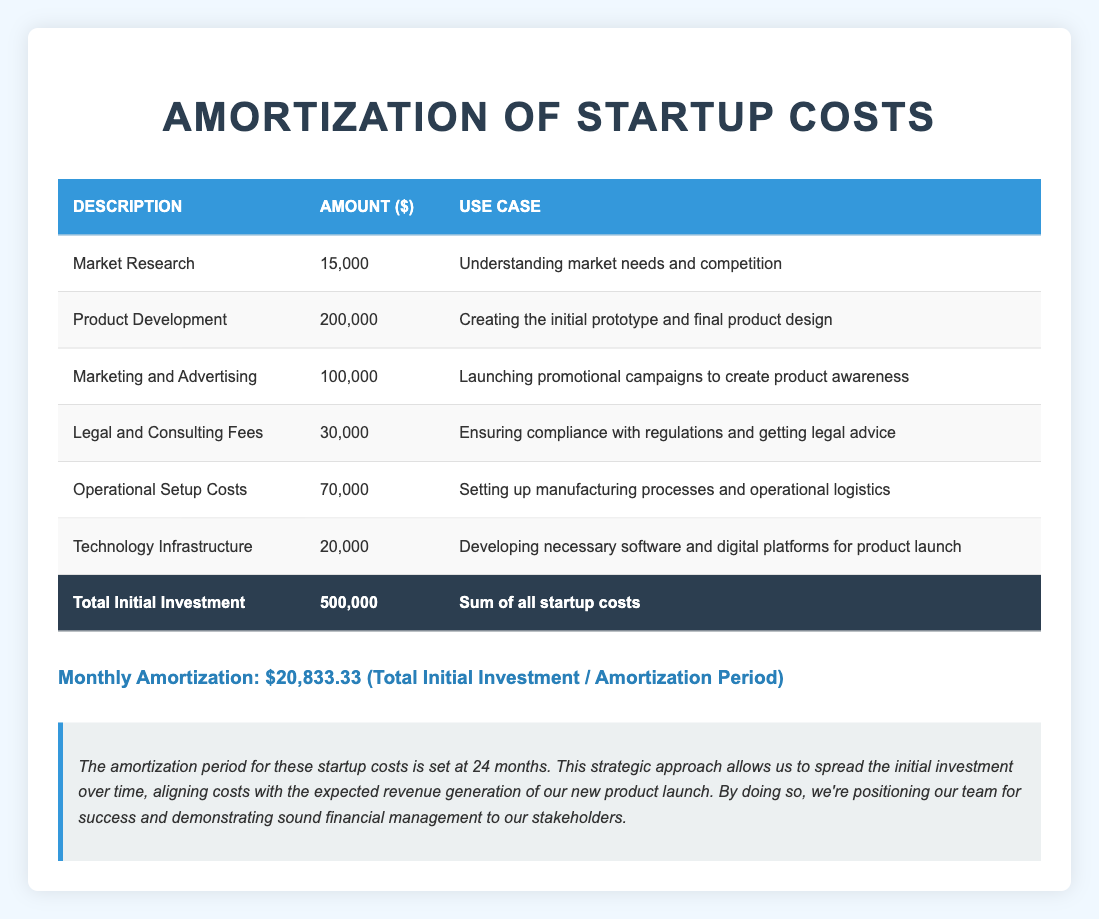What is the total amount allocated for product development? The total amount allocated for product development can be directly found in the table. It states "Product Development" and shows the amount of 200,000.
Answer: 200,000 What is the total initial investment for the startup costs? The total initial investment is listed at the bottom of the table as "Total Initial Investment" which shows 500,000.
Answer: 500,000 How much is allocated for marketing and advertising? The table indicates that the allocated amount for "Marketing and Advertising" is 100,000.
Answer: 100,000 Is the amount spent on legal and consulting fees more than the amount spent on technology infrastructure? By comparing the values in the table, the amount for "Legal and Consulting Fees" is 30,000 and for "Technology Infrastructure" is 20,000. Since 30,000 is greater than 20,000, the answer is yes.
Answer: Yes What is the monthly amortization amount based on the total initial investment? The monthly amortization can be calculated by dividing the total initial investment (500,000) by the amortization period (24 months): 500,000 / 24 = 20,833.33.
Answer: 20,833.33 What is the total amount allocated for market research and operational setup costs together? To find the total, we need to add the amounts for "Market Research" (15,000) and "Operational Setup Costs" (70,000). Thus, 15,000 + 70,000 = 85,000.
Answer: 85,000 What percentage of the total startup costs is spent on technology infrastructure? First, we find the amount spent on "Technology Infrastructure" (20,000). The total startup costs are 500,000. Then, we calculate the percentage: (20,000 / 500,000) * 100 = 4%.
Answer: 4% How much more is allocated for product development compared to legal and consulting fees? We can find the difference by subtracting the amount for "Legal and Consulting Fees" (30,000) from "Product Development" (200,000): 200,000 - 30,000 = 170,000.
Answer: 170,000 Is the total investment in marketing and advertising less than the total investment in market research and technology infrastructure combined? Adding "Marketing and Advertising" (100,000) and comparing it with the sum of "Market Research" (15,000) and "Technology Infrastructure" (20,000): 15,000 + 20,000 = 35,000. Since 100,000 is greater than 35,000, the answer is no.
Answer: No 